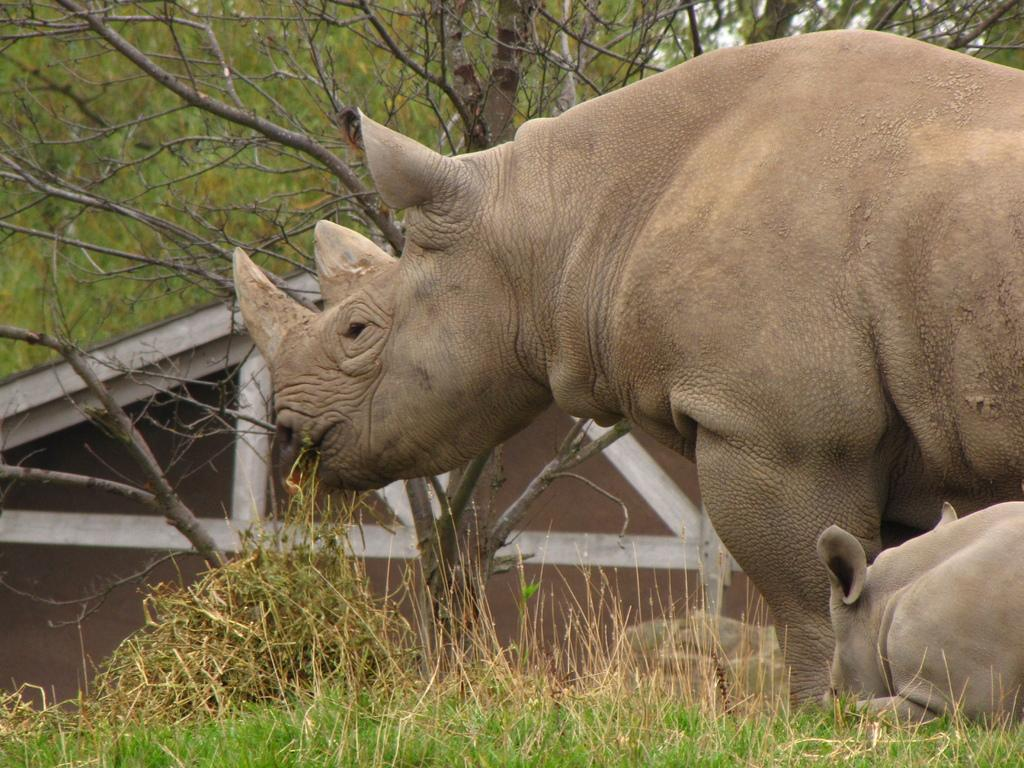What types of animals can be seen on the ground in the image? There are two animals on the ground in the image. What type of vegetation is present in the image? There are trees and grass in the image. What type of structure is visible in the image? There is a house in the image. What part of the natural environment is visible in the image? The sky is visible in the image. What type of stem can be seen growing from the window in the image? There is no stem or window present in the image. 